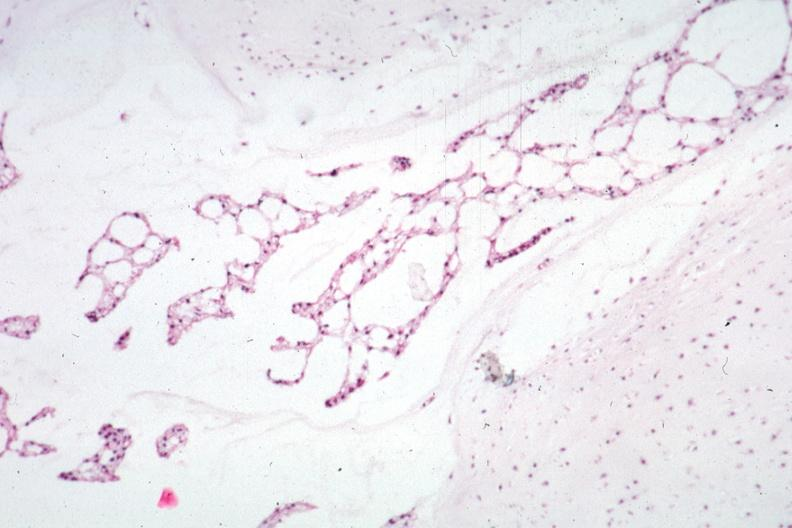was this section taken?
Answer the question using a single word or phrase. Yes 